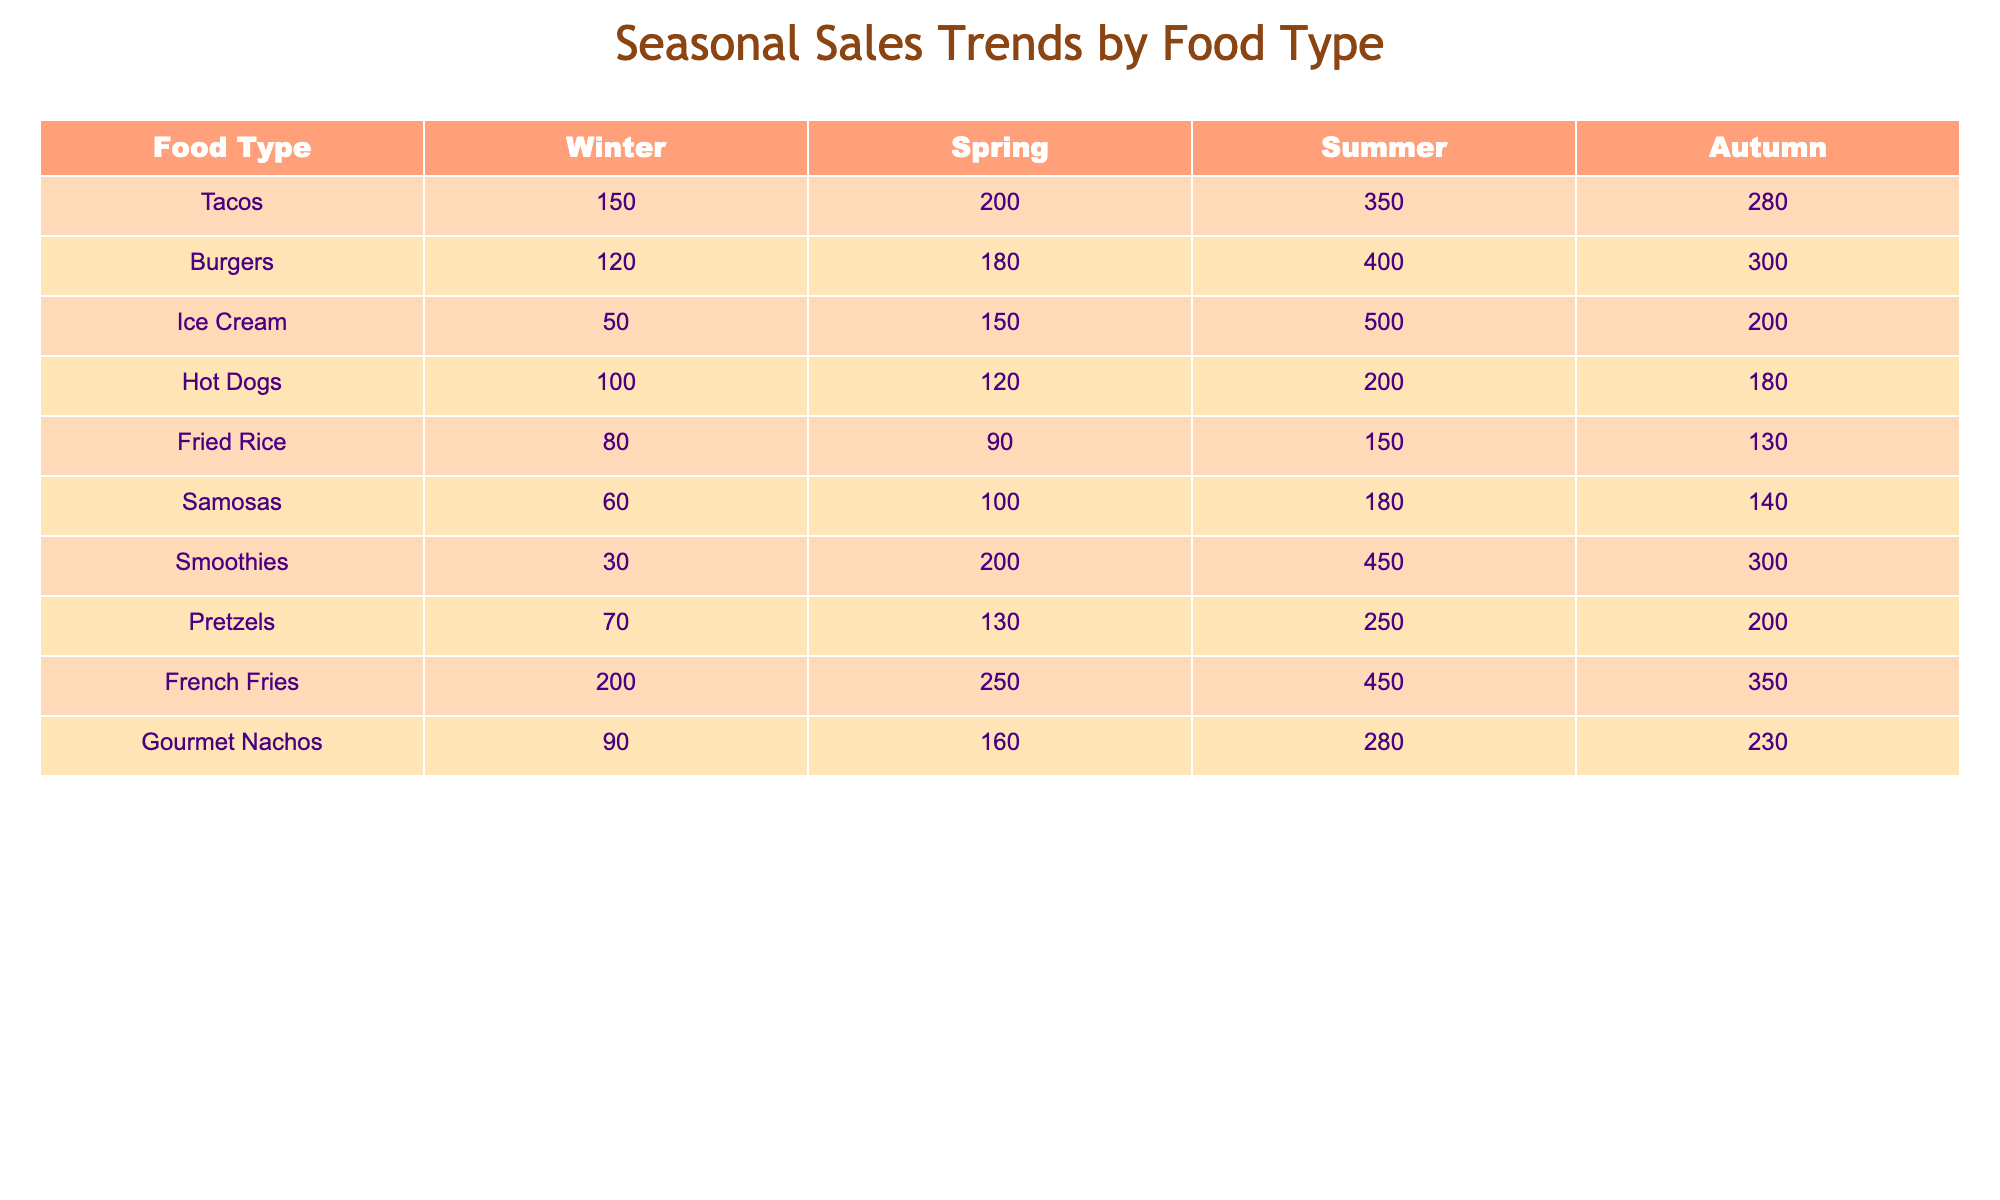What is the highest sales figure for Ice Cream and which season does it occur in? Looking at the Ice Cream row, the highest sales figure is 500, which occurs in the Summer season.
Answer: 500 in Summer Which food type has the lowest sales in Winter? In the Winter column, the sales figures are: Tacos (150), Burgers (120), Ice Cream (50), Hot Dogs (100), Fried Rice (80), Samosas (60), Smoothies (30), Pretzels (70), French Fries (200), and Gourmet Nachos (90). The minimum value is 30 for Smoothies.
Answer: Smoothies What is the total sales of Burgers and Hot Dogs in Spring? Adding the Spring sales of both food types: Burgers sales (180) + Hot Dogs sales (120) equals 300.
Answer: 300 Are French Fries more popular than Tacos in Summer? The sales for Summer are: French Fries (450) and Tacos (350). Since 450 is greater than 350, French Fries are indeed more popular.
Answer: Yes What is the average sales for Smoothies across all seasons? To find the average for Smoothies, add the sales figures: Winter (30) + Spring (200) + Summer (450) + Autumn (300) = 980. The average is 980 divided by 4, resulting in 245.
Answer: 245 Which food type has the biggest difference between Summer and Winter sales? Calculate the differences for each food type: Tacos (350 - 150 = 200), Burgers (400 - 120 = 280), Ice Cream (500 - 50 = 450), Hot Dogs (200 - 100 = 100), Fried Rice (150 - 80 = 70), Samosas (180 - 60 = 120), Smoothies (450 - 30 = 420), Pretzels (250 - 70 = 180), French Fries (450 - 200 = 250), Gourmet Nachos (280 - 90 = 190). The largest difference is 450 for Ice Cream.
Answer: Ice Cream Is the sales trend for Tacos and Burgers similar in Autumn? In Autumn, Tacos have 280 and Burgers have 300. Since both values are relatively close, we can consider their trends similar.
Answer: Yes What season had the highest sales for Fried Rice? Reviewing the Fried Rice row, the summer sales are 150, which is the highest compared to the other seasons (Winter 80, Spring 90, Autumn 130).
Answer: Summer What is the total sales across all seasons for Gourmet Nachos? Gourmet Nachos sales are: Winter (90) + Spring (160) + Summer (280) + Autumn (230) = 760.
Answer: 760 